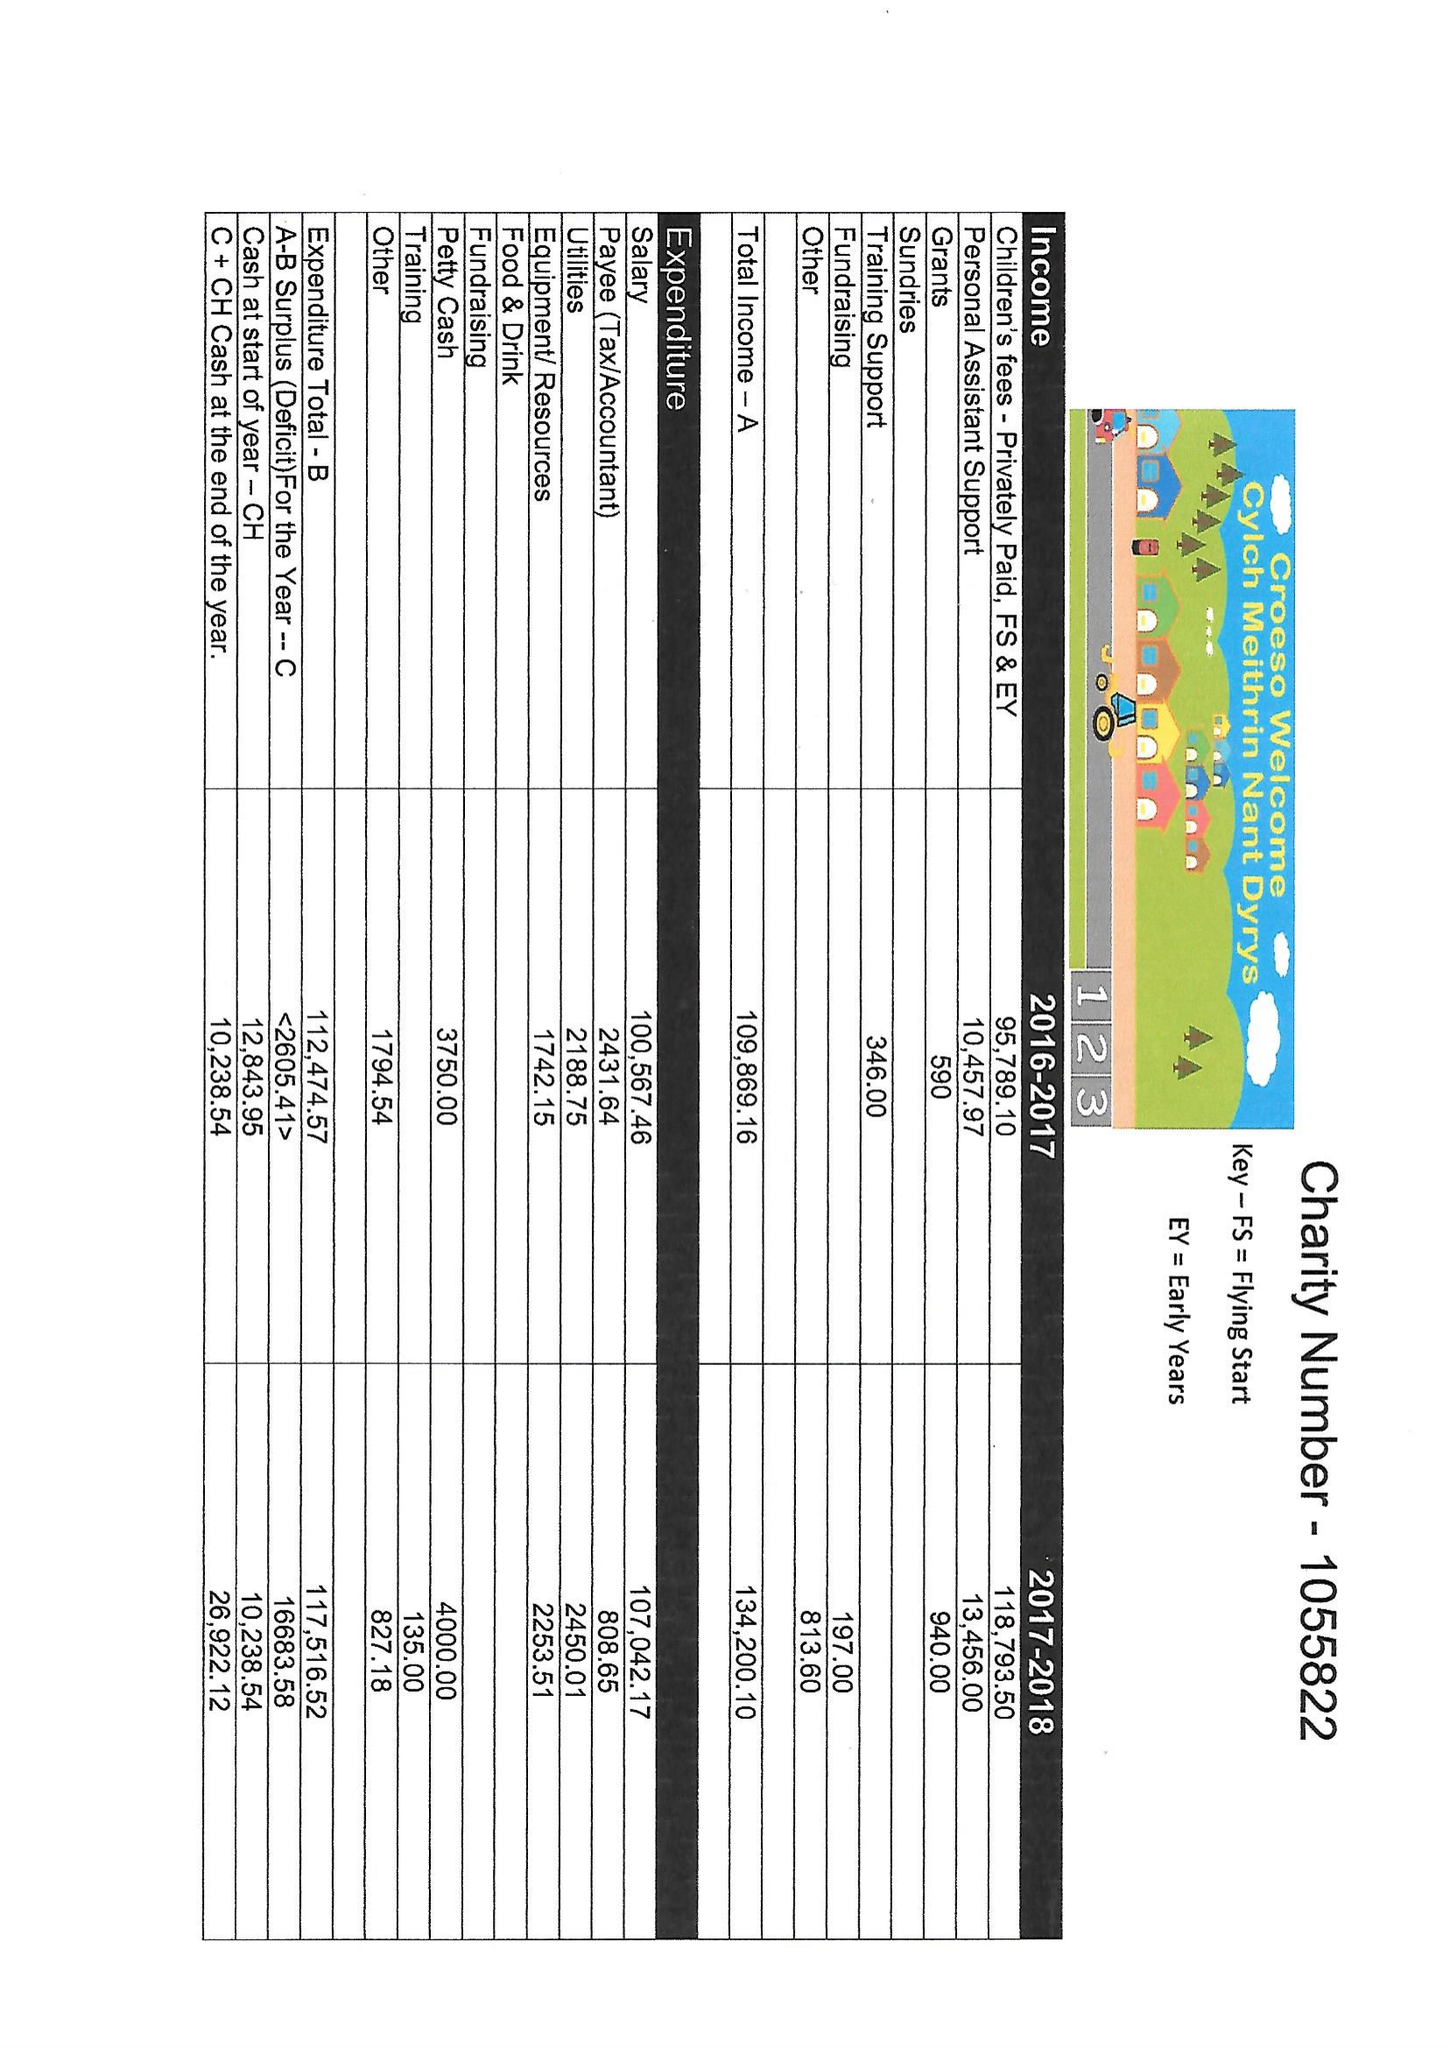What is the value for the charity_number?
Answer the question using a single word or phrase. 1055822 